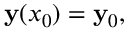Convert formula to latex. <formula><loc_0><loc_0><loc_500><loc_500>y ( x _ { 0 } ) = y _ { 0 } ,</formula> 